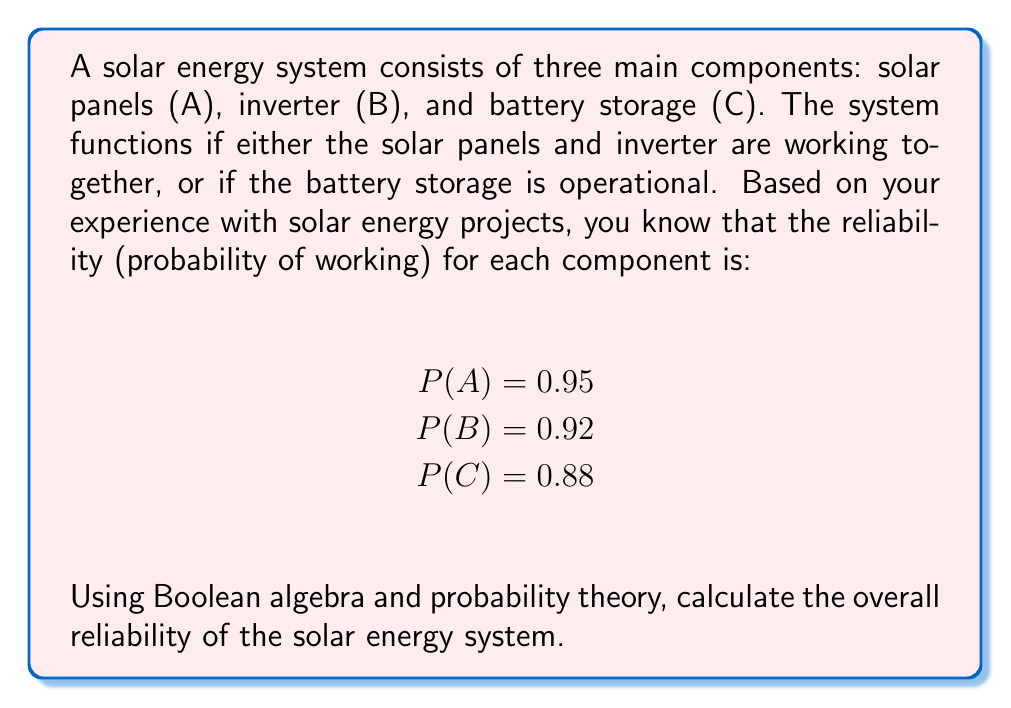Show me your answer to this math problem. To solve this problem, we'll follow these steps:

1. Express the system's functionality using Boolean algebra
2. Convert the Boolean expression to a probability equation
3. Apply the given probabilities and calculate the result

Step 1: Boolean expression
The system works if (A AND B) OR C. We can write this as:
$$ F = (A \wedge B) \vee C $$

Step 2: Convert to probability equation
Using the inclusion-exclusion principle, we can convert this to:
$$ P(F) = P(A \wedge B) + P(C) - P((A \wedge B) \wedge C) $$

Step 3: Apply probabilities and calculate
a) $P(A \wedge B) = P(A) \cdot P(B) = 0.95 \cdot 0.92 = 0.874$

b) $P(C) = 0.88$

c) $P((A \wedge B) \wedge C) = P(A) \cdot P(B) \cdot P(C) = 0.95 \cdot 0.92 \cdot 0.88 = 0.76912$

Now, we can substitute these values into our equation:

$$ P(F) = 0.874 + 0.88 - 0.76912 $$
$$ P(F) = 0.98488 $$

Therefore, the overall reliability of the solar energy system is approximately 0.9849 or 98.49%.
Answer: 0.9849 (or 98.49%) 